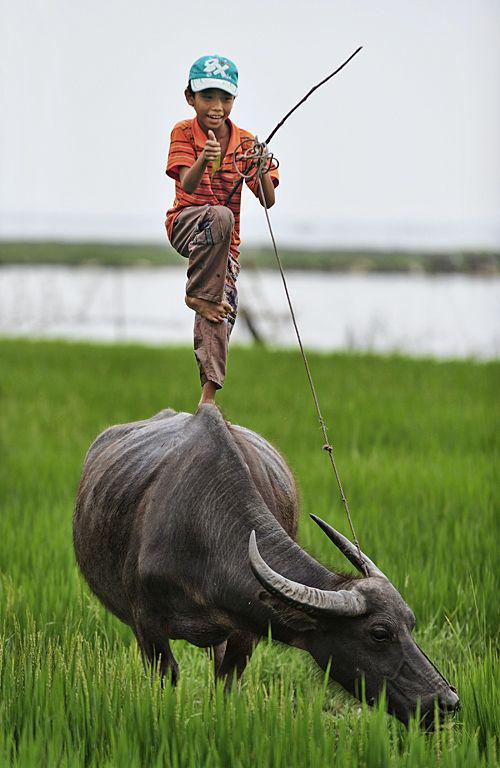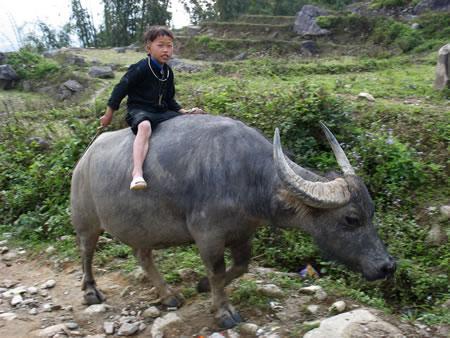The first image is the image on the left, the second image is the image on the right. Given the left and right images, does the statement "In at least one image there are three males with short black hair and at least one male is riding an ox." hold true? Answer yes or no. No. The first image is the image on the left, the second image is the image on the right. Evaluate the accuracy of this statement regarding the images: "The right image shows a child straddling the back of a right-facing water buffalo, and the left image shows a boy holding a stick extended forward while on the back of a water buffalo.". Is it true? Answer yes or no. Yes. 